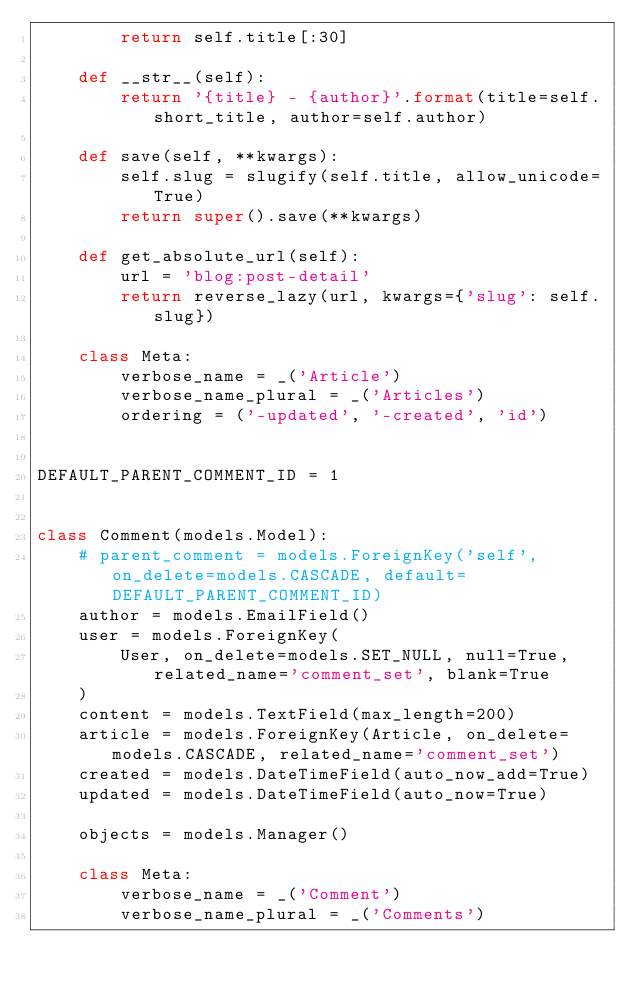<code> <loc_0><loc_0><loc_500><loc_500><_Python_>        return self.title[:30]

    def __str__(self):
        return '{title} - {author}'.format(title=self.short_title, author=self.author)

    def save(self, **kwargs):
        self.slug = slugify(self.title, allow_unicode=True)
        return super().save(**kwargs)

    def get_absolute_url(self):
        url = 'blog:post-detail'
        return reverse_lazy(url, kwargs={'slug': self.slug})

    class Meta:
        verbose_name = _('Article')
        verbose_name_plural = _('Articles')
        ordering = ('-updated', '-created', 'id')


DEFAULT_PARENT_COMMENT_ID = 1


class Comment(models.Model):
    # parent_comment = models.ForeignKey('self', on_delete=models.CASCADE, default=DEFAULT_PARENT_COMMENT_ID)
    author = models.EmailField()
    user = models.ForeignKey(
        User, on_delete=models.SET_NULL, null=True, related_name='comment_set', blank=True
    )
    content = models.TextField(max_length=200)
    article = models.ForeignKey(Article, on_delete=models.CASCADE, related_name='comment_set')
    created = models.DateTimeField(auto_now_add=True)
    updated = models.DateTimeField(auto_now=True)

    objects = models.Manager()

    class Meta:
        verbose_name = _('Comment')
        verbose_name_plural = _('Comments')
</code> 